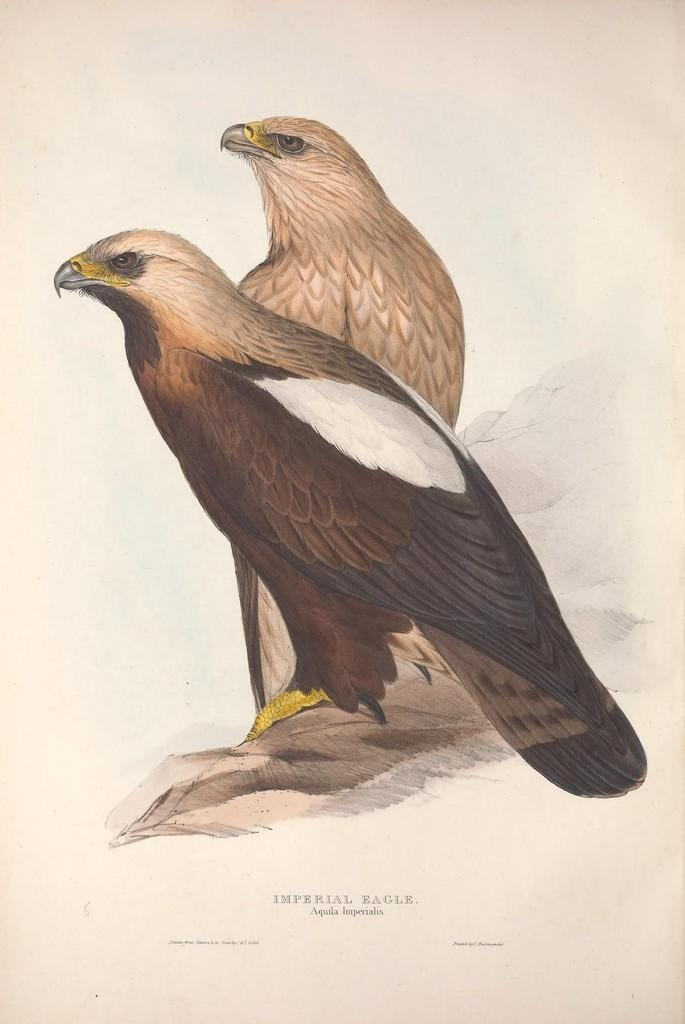How many birds are visible in the image? There are two birds in the image. Where are the birds located? The birds are on a platform in the image. What else can be seen in the image besides the birds? There is some text in the image. What is the color of the background in the image? The background color is cream. What type of arch can be seen in the image? There is no arch present in the image. How does the cracker contribute to the loss experienced by the birds in the image? There is no cracker or loss mentioned in the image; it only features two birds on a platform and some text. 